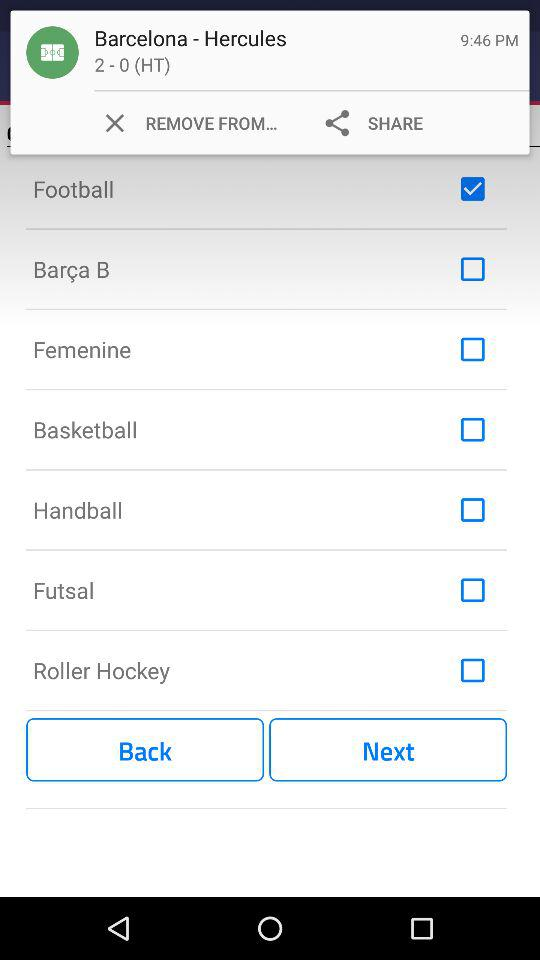What is the status of the "Football"? The status is "on". 